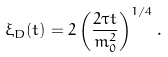<formula> <loc_0><loc_0><loc_500><loc_500>\xi _ { D } ( t ) = 2 \left ( \frac { 2 \tau t } { m _ { 0 } ^ { 2 } } \right ) ^ { 1 / 4 } .</formula> 